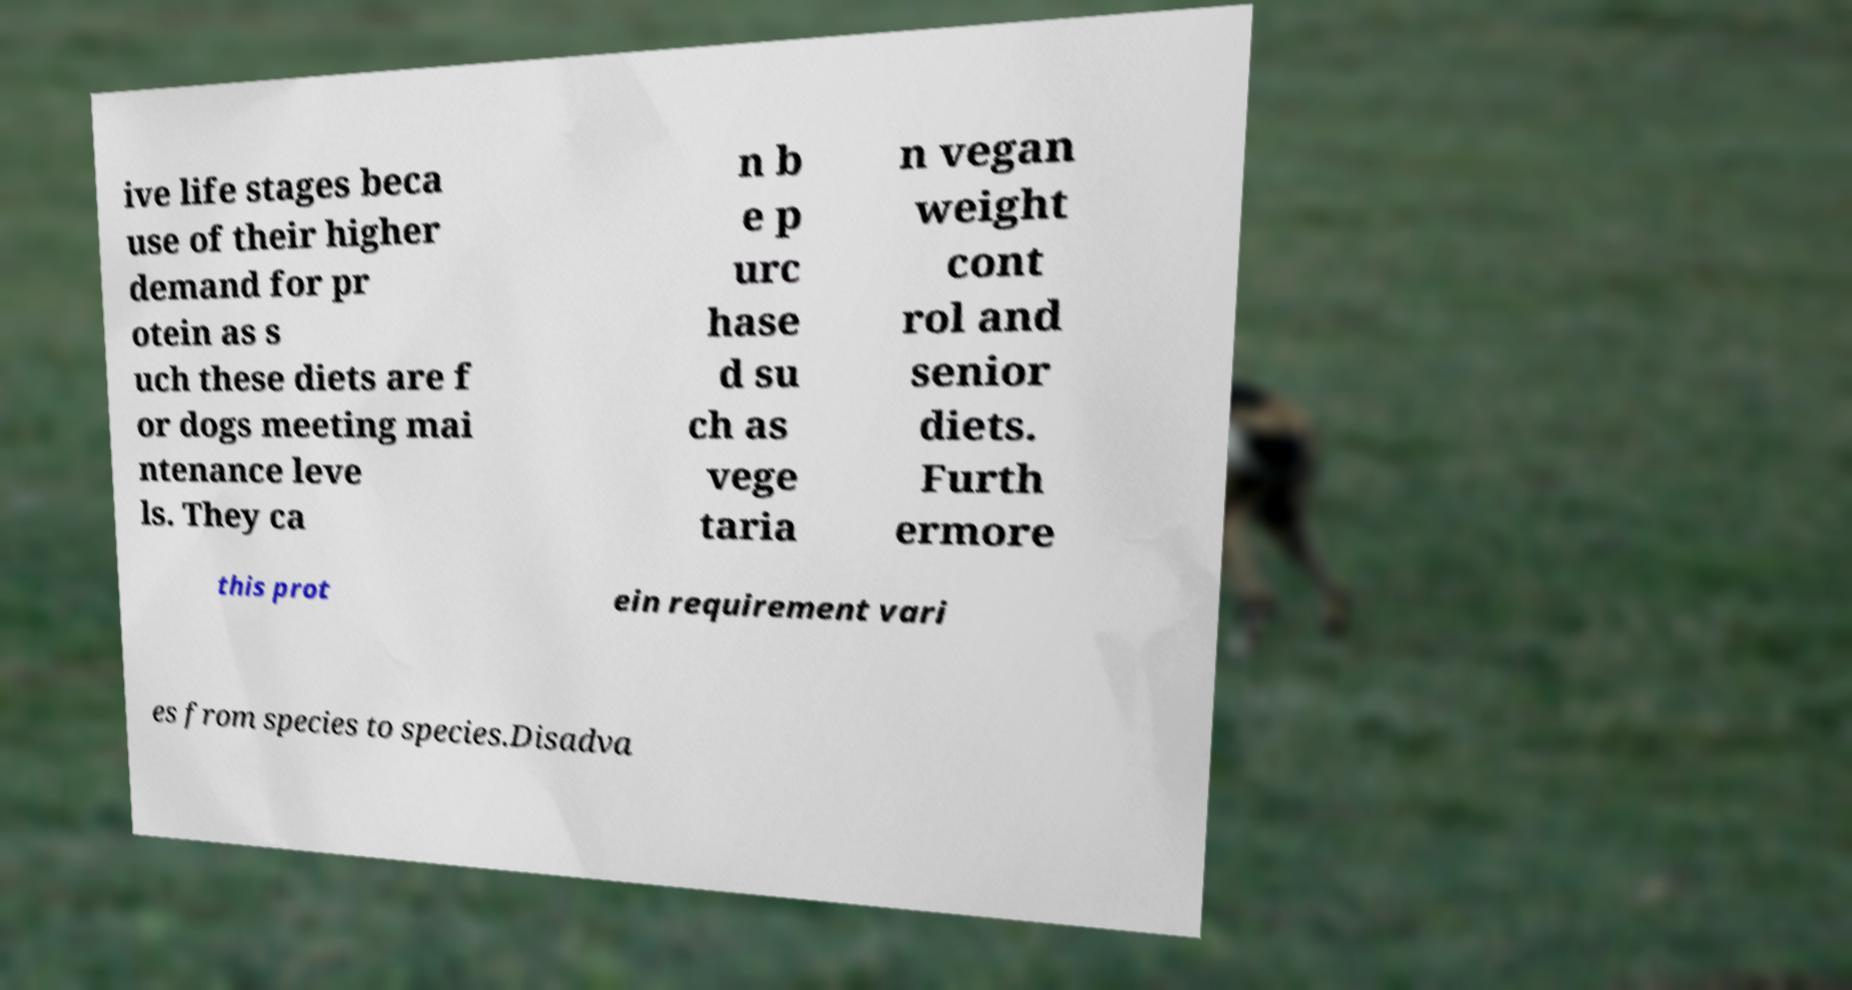What messages or text are displayed in this image? I need them in a readable, typed format. ive life stages beca use of their higher demand for pr otein as s uch these diets are f or dogs meeting mai ntenance leve ls. They ca n b e p urc hase d su ch as vege taria n vegan weight cont rol and senior diets. Furth ermore this prot ein requirement vari es from species to species.Disadva 